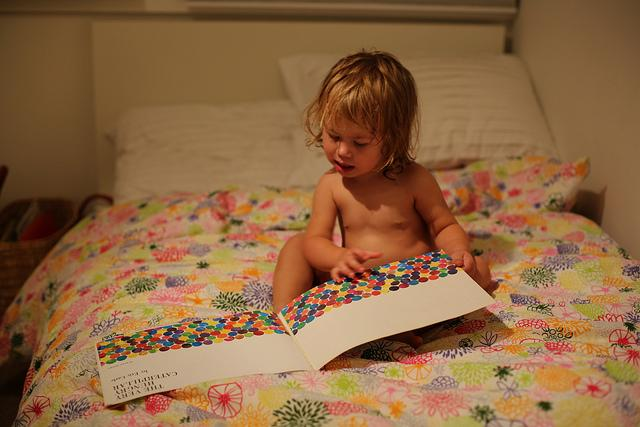On what does the child focus here?

Choices:
A) words
B) dots
C) white space
D) music dots 